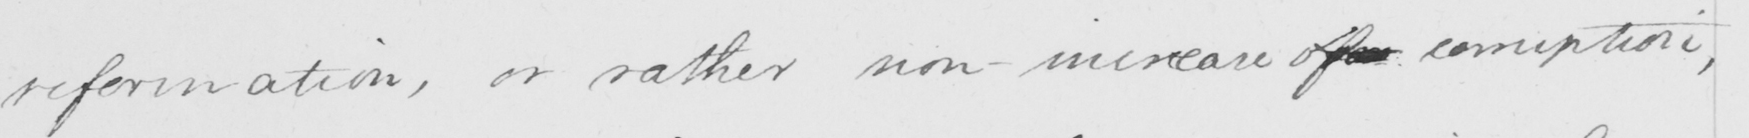Transcribe the text shown in this historical manuscript line. reformation , or rather non _ increase ofor corruption , 